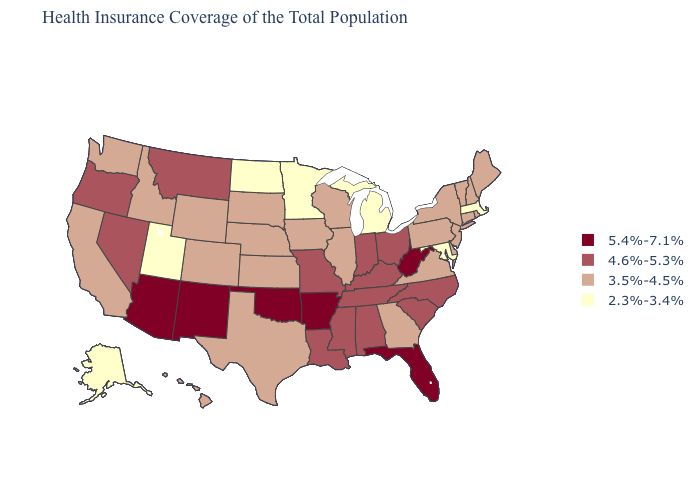What is the highest value in states that border Arkansas?
Give a very brief answer. 5.4%-7.1%. What is the value of Arizona?
Give a very brief answer. 5.4%-7.1%. Name the states that have a value in the range 2.3%-3.4%?
Give a very brief answer. Alaska, Maryland, Massachusetts, Michigan, Minnesota, North Dakota, Utah. What is the lowest value in states that border Mississippi?
Give a very brief answer. 4.6%-5.3%. Which states have the lowest value in the MidWest?
Short answer required. Michigan, Minnesota, North Dakota. Name the states that have a value in the range 3.5%-4.5%?
Give a very brief answer. California, Colorado, Connecticut, Delaware, Georgia, Hawaii, Idaho, Illinois, Iowa, Kansas, Maine, Nebraska, New Hampshire, New Jersey, New York, Pennsylvania, Rhode Island, South Dakota, Texas, Vermont, Virginia, Washington, Wisconsin, Wyoming. Does California have a lower value than Oregon?
Keep it brief. Yes. Among the states that border Wisconsin , does Michigan have the lowest value?
Give a very brief answer. Yes. How many symbols are there in the legend?
Write a very short answer. 4. Which states have the lowest value in the USA?
Give a very brief answer. Alaska, Maryland, Massachusetts, Michigan, Minnesota, North Dakota, Utah. Name the states that have a value in the range 3.5%-4.5%?
Give a very brief answer. California, Colorado, Connecticut, Delaware, Georgia, Hawaii, Idaho, Illinois, Iowa, Kansas, Maine, Nebraska, New Hampshire, New Jersey, New York, Pennsylvania, Rhode Island, South Dakota, Texas, Vermont, Virginia, Washington, Wisconsin, Wyoming. Among the states that border Alabama , which have the highest value?
Concise answer only. Florida. Does Nevada have a lower value than Florida?
Keep it brief. Yes. Name the states that have a value in the range 3.5%-4.5%?
Be succinct. California, Colorado, Connecticut, Delaware, Georgia, Hawaii, Idaho, Illinois, Iowa, Kansas, Maine, Nebraska, New Hampshire, New Jersey, New York, Pennsylvania, Rhode Island, South Dakota, Texas, Vermont, Virginia, Washington, Wisconsin, Wyoming. Which states have the lowest value in the West?
Concise answer only. Alaska, Utah. 